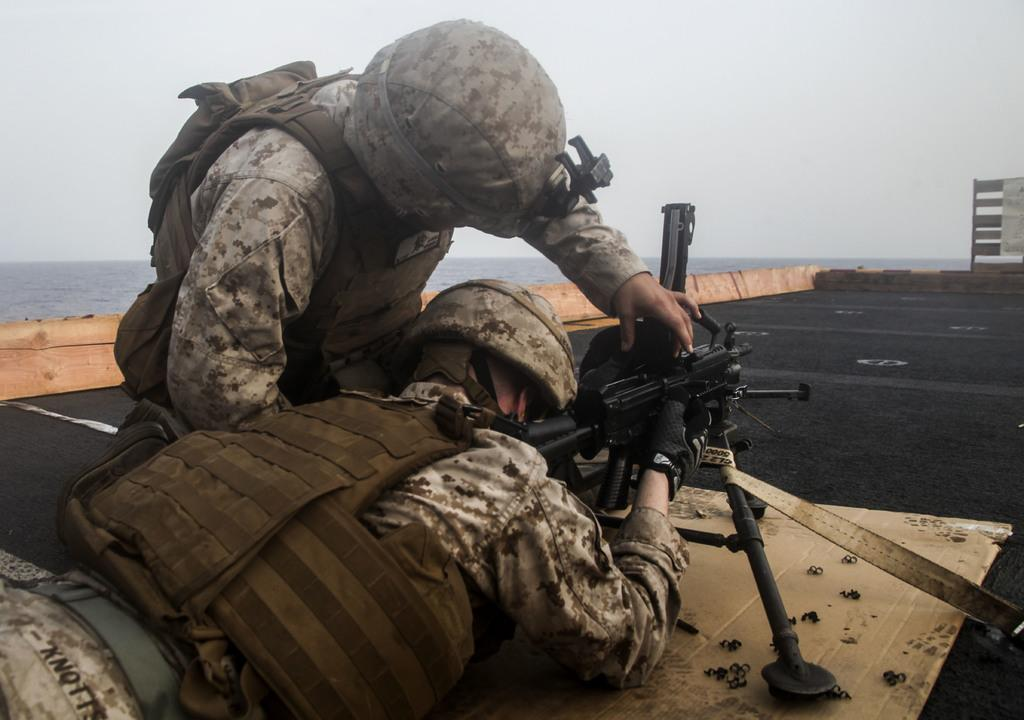How many people are in the image? There are two people in the center of the image. What are the people wearing? The people are wearing uniforms. What are the people doing in the image? The people are using weapons. What can be seen in the background of the image? There is water in the background of the image. What is visible above the water in the image? The sky is visible in the image. Where is the cactus located in the image? There is no cactus present in the image. How does the snow affect the people's uniforms in the image? There is no snow present in the image, so it does not affect the people's uniforms. 